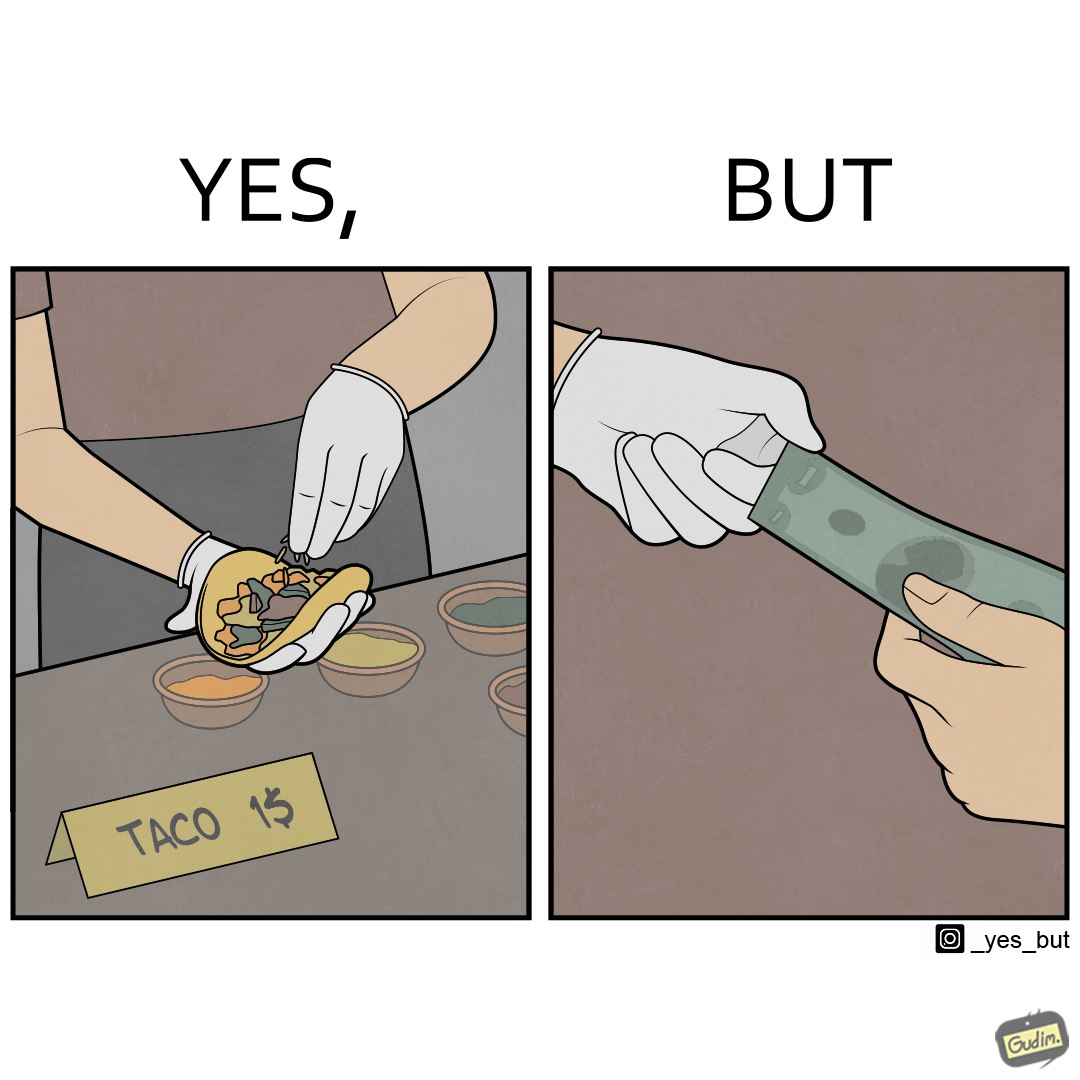Is there satirical content in this image? Yes, this image is satirical. 